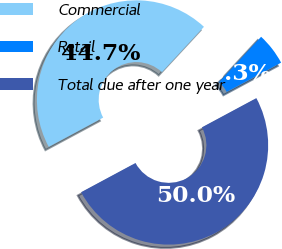Convert chart. <chart><loc_0><loc_0><loc_500><loc_500><pie_chart><fcel>Commercial<fcel>Retail<fcel>Total due after one year<nl><fcel>44.74%<fcel>5.26%<fcel>50.0%<nl></chart> 